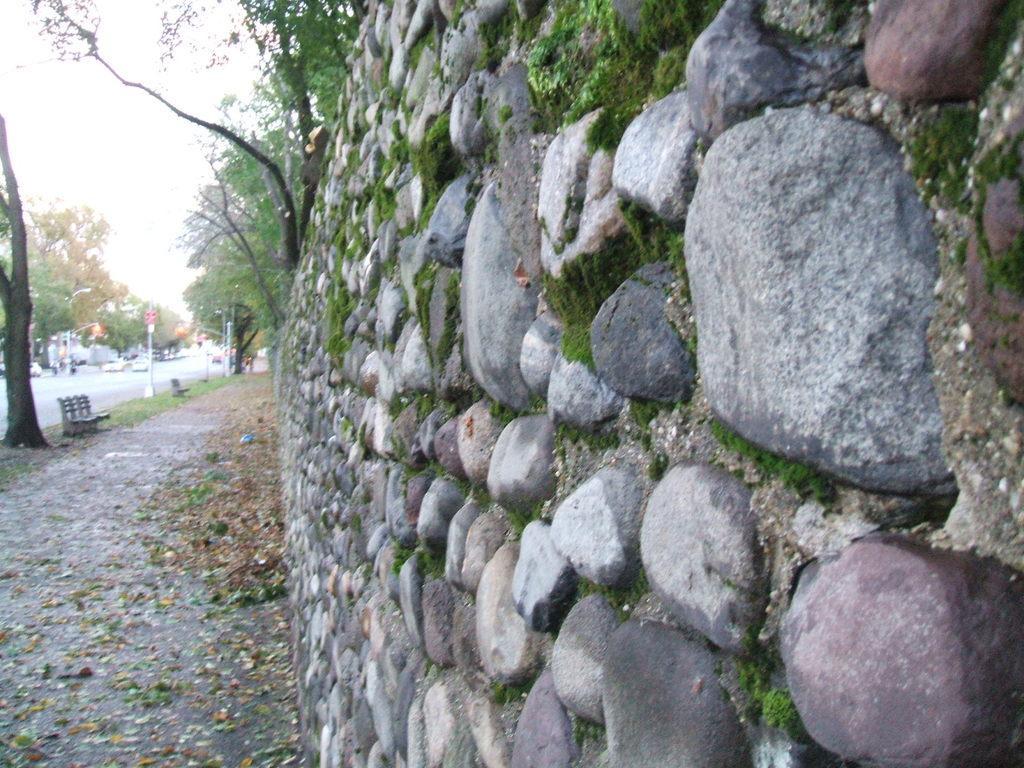Please provide a concise description of this image. In this picture we can see a stone wall and on the left side of the wall there is a bench, trees, poles and some vehicles on the road. Behind the trees there is a sky. 